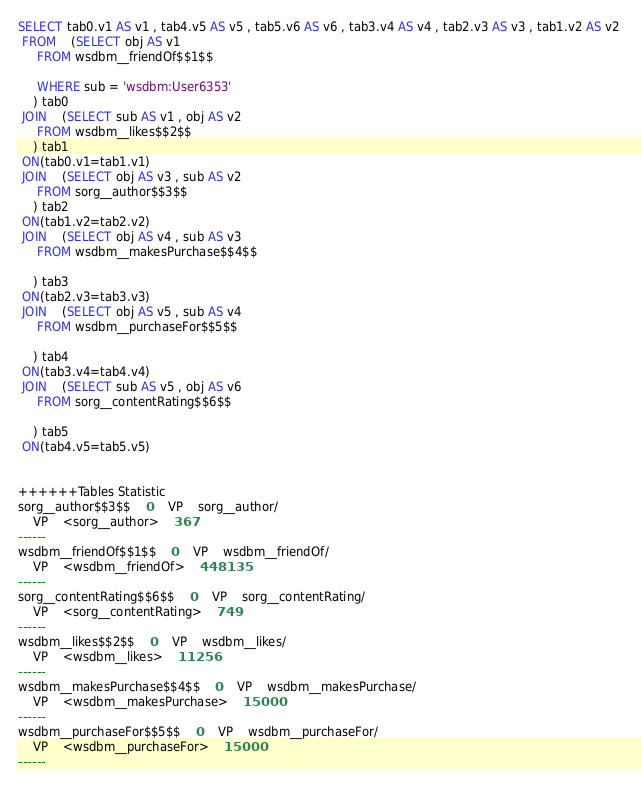<code> <loc_0><loc_0><loc_500><loc_500><_SQL_>SELECT tab0.v1 AS v1 , tab4.v5 AS v5 , tab5.v6 AS v6 , tab3.v4 AS v4 , tab2.v3 AS v3 , tab1.v2 AS v2 
 FROM    (SELECT obj AS v1 
	 FROM wsdbm__friendOf$$1$$
	 
	 WHERE sub = 'wsdbm:User6353'
	) tab0
 JOIN    (SELECT sub AS v1 , obj AS v2 
	 FROM wsdbm__likes$$2$$
	) tab1
 ON(tab0.v1=tab1.v1)
 JOIN    (SELECT obj AS v3 , sub AS v2 
	 FROM sorg__author$$3$$
	) tab2
 ON(tab1.v2=tab2.v2)
 JOIN    (SELECT obj AS v4 , sub AS v3 
	 FROM wsdbm__makesPurchase$$4$$
	
	) tab3
 ON(tab2.v3=tab3.v3)
 JOIN    (SELECT obj AS v5 , sub AS v4 
	 FROM wsdbm__purchaseFor$$5$$
	
	) tab4
 ON(tab3.v4=tab4.v4)
 JOIN    (SELECT sub AS v5 , obj AS v6 
	 FROM sorg__contentRating$$6$$
	
	) tab5
 ON(tab4.v5=tab5.v5)


++++++Tables Statistic
sorg__author$$3$$	0	VP	sorg__author/
	VP	<sorg__author>	367
------
wsdbm__friendOf$$1$$	0	VP	wsdbm__friendOf/
	VP	<wsdbm__friendOf>	448135
------
sorg__contentRating$$6$$	0	VP	sorg__contentRating/
	VP	<sorg__contentRating>	749
------
wsdbm__likes$$2$$	0	VP	wsdbm__likes/
	VP	<wsdbm__likes>	11256
------
wsdbm__makesPurchase$$4$$	0	VP	wsdbm__makesPurchase/
	VP	<wsdbm__makesPurchase>	15000
------
wsdbm__purchaseFor$$5$$	0	VP	wsdbm__purchaseFor/
	VP	<wsdbm__purchaseFor>	15000
------
</code> 